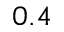<formula> <loc_0><loc_0><loc_500><loc_500>0 . 4</formula> 